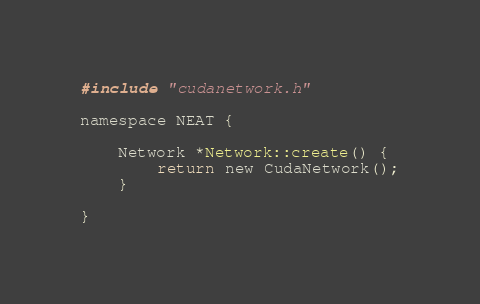Convert code to text. <code><loc_0><loc_0><loc_500><loc_500><_Cuda_>#include "cudanetwork.h"

namespace NEAT {
 
    Network *Network::create() {
        return new CudaNetwork();
    }

}
</code> 